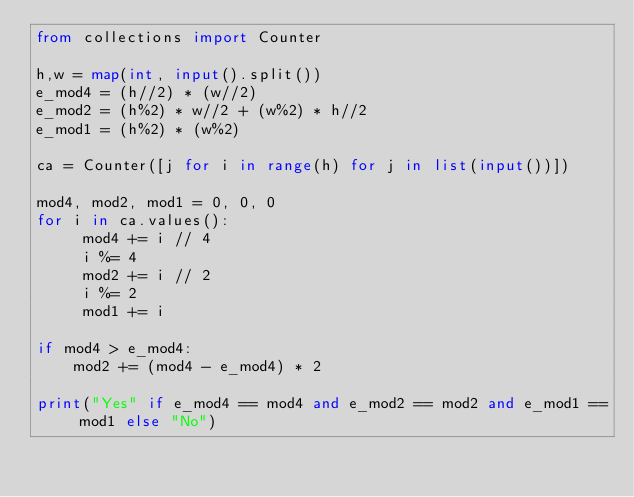<code> <loc_0><loc_0><loc_500><loc_500><_Python_>from collections import Counter

h,w = map(int, input().split())
e_mod4 = (h//2) * (w//2)
e_mod2 = (h%2) * w//2 + (w%2) * h//2
e_mod1 = (h%2) * (w%2)

ca = Counter([j for i in range(h) for j in list(input())])

mod4, mod2, mod1 = 0, 0, 0
for i in ca.values():
     mod4 += i // 4
     i %= 4
     mod2 += i // 2
     i %= 2
     mod1 += i

if mod4 > e_mod4:
    mod2 += (mod4 - e_mod4) * 2

print("Yes" if e_mod4 == mod4 and e_mod2 == mod2 and e_mod1 == mod1 else "No")</code> 